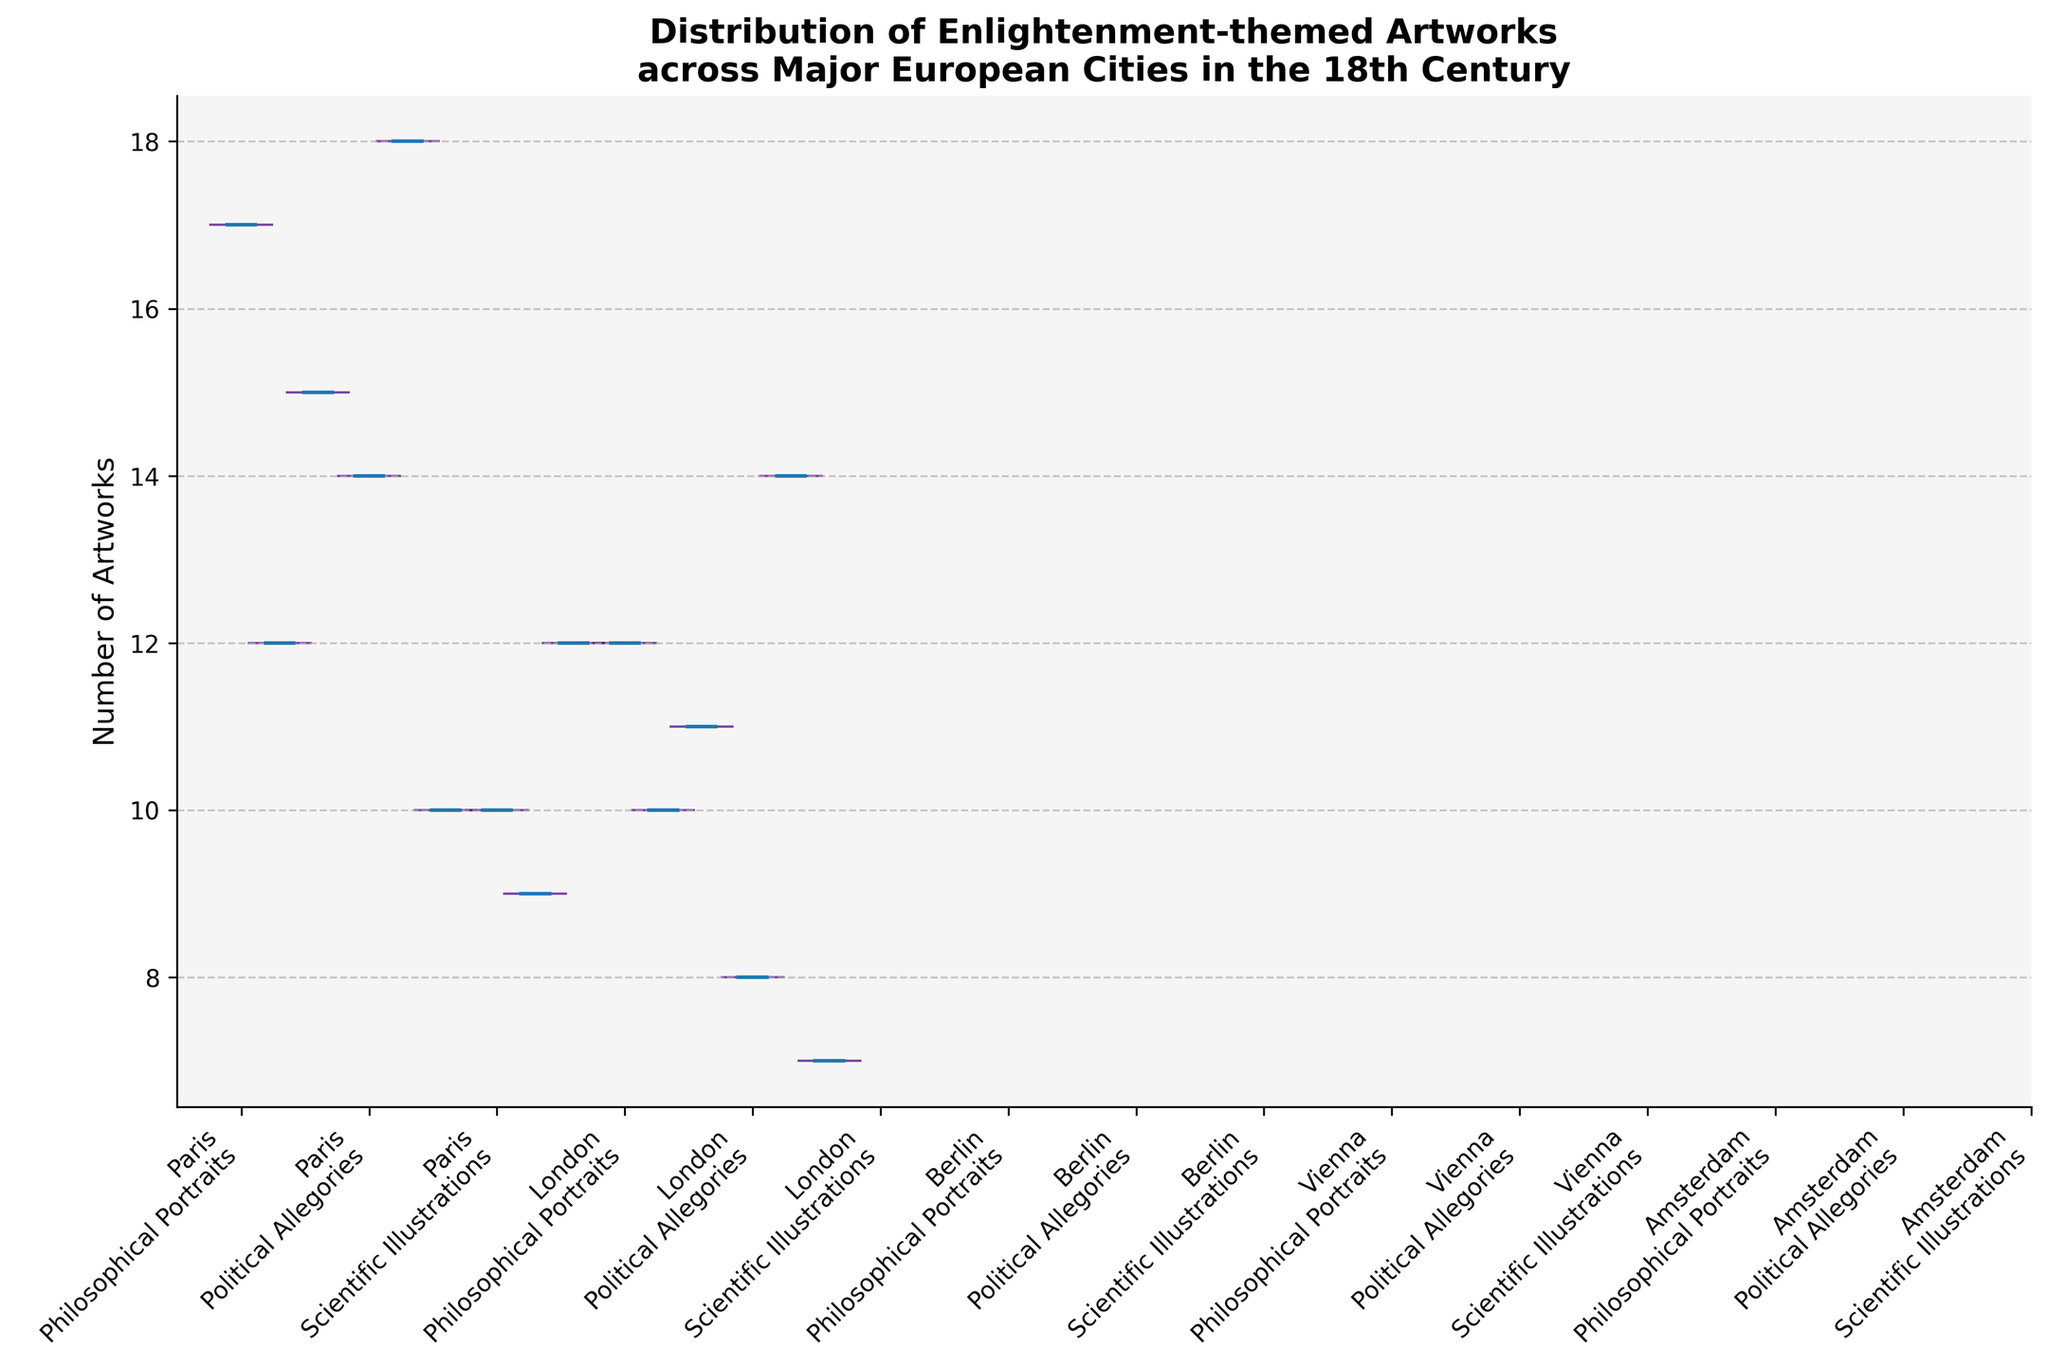what is the title of the figure? The title is large text located at the top of the figure that describes what the chart is about.
Answer: Distribution of Enlightenment-themed Artworks across Major European Cities in the 18th Century what city has the highest median number of artworks for Political Allegories? To find this, look at the different city-artwork combinations and find which box has the highest median line in the Political Allegories category.
Answer: London which city has the smallest range in the number of Philosophical Portraits? Look at the length of the violins for Philosophical Portraits in each city to determine which has the smallest range.
Answer: Amsterdam compare the range of Scientific Illustrations between Berlin and Vienna. Which city shows a wider range? Observe the length of the violins for Scientific Illustrations in both Berlin and Vienna, and see which one stretches out further.
Answer: Berlin which artwork type in Paris has the highest range of number of artworks? Check the violins for Paris and see which one among Philosophical Portraits, Political Allegories, and Scientific Illustrations is the longest, indicating the highest range.
Answer: Philosophical Portraits does London have more artworks in the Political Allegories category compared to Berlin? Look at the violin chart for Political Allegories for both London and Berlin and compare their ranges and median values.
Answer: Yes what is the general trend for the number of artworks across the various cities for Scientific Illustrations? Look at the violins for Scientific Illustrations across all the cities and summarize the pattern you see.
Answer: Relatively consistent with no extreme outliers how does the median number of Philosophical Portraits in Paris compare to Vienna? Look at the median line of the Philosophical Portraits violins for both cities and compare their positions.
Answer: Paris has a higher median which city has the overall highest median number of artworks across all categories? To determine this, consider the median lines across all artwork types for each city, and sum up or visually identify the city with consistently higher medians.
Answer: Paris 